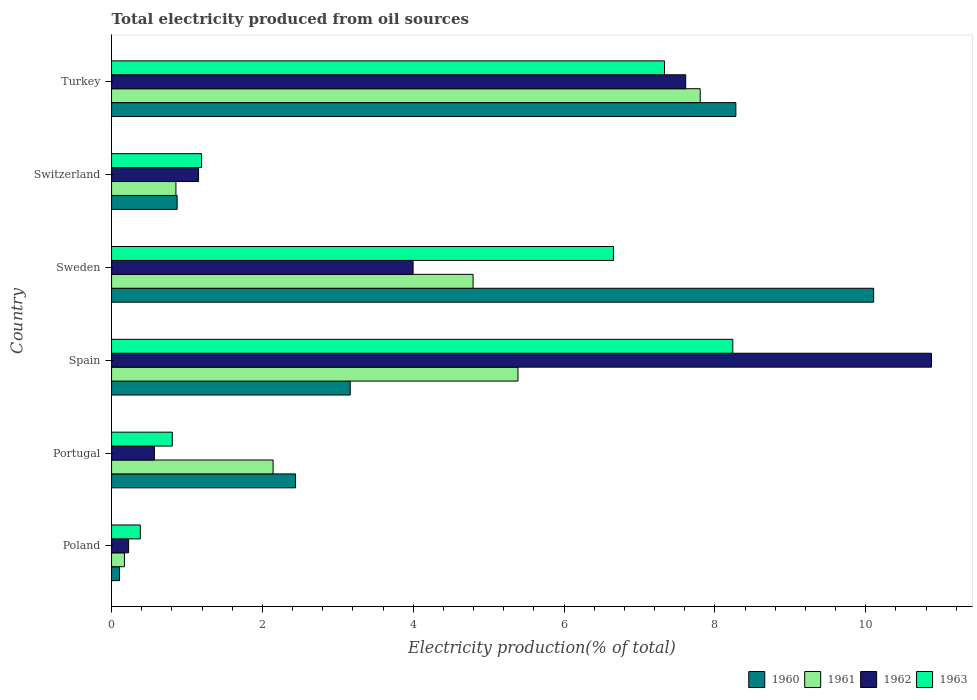Are the number of bars per tick equal to the number of legend labels?
Keep it short and to the point. Yes. What is the label of the 2nd group of bars from the top?
Keep it short and to the point. Switzerland. In how many cases, is the number of bars for a given country not equal to the number of legend labels?
Make the answer very short. 0. What is the total electricity produced in 1960 in Portugal?
Your response must be concise. 2.44. Across all countries, what is the maximum total electricity produced in 1962?
Provide a short and direct response. 10.87. Across all countries, what is the minimum total electricity produced in 1963?
Your response must be concise. 0.38. In which country was the total electricity produced in 1963 maximum?
Ensure brevity in your answer.  Spain. In which country was the total electricity produced in 1963 minimum?
Provide a short and direct response. Poland. What is the total total electricity produced in 1961 in the graph?
Provide a short and direct response. 21.15. What is the difference between the total electricity produced in 1963 in Poland and that in Switzerland?
Provide a short and direct response. -0.81. What is the difference between the total electricity produced in 1963 in Portugal and the total electricity produced in 1962 in Spain?
Offer a terse response. -10.07. What is the average total electricity produced in 1962 per country?
Your response must be concise. 4.07. What is the difference between the total electricity produced in 1961 and total electricity produced in 1960 in Portugal?
Your response must be concise. -0.3. What is the ratio of the total electricity produced in 1963 in Portugal to that in Spain?
Your answer should be very brief. 0.1. Is the difference between the total electricity produced in 1961 in Poland and Portugal greater than the difference between the total electricity produced in 1960 in Poland and Portugal?
Make the answer very short. Yes. What is the difference between the highest and the second highest total electricity produced in 1962?
Ensure brevity in your answer.  3.26. What is the difference between the highest and the lowest total electricity produced in 1960?
Provide a short and direct response. 10. In how many countries, is the total electricity produced in 1961 greater than the average total electricity produced in 1961 taken over all countries?
Offer a very short reply. 3. What does the 1st bar from the top in Switzerland represents?
Your answer should be compact. 1963. Is it the case that in every country, the sum of the total electricity produced in 1961 and total electricity produced in 1960 is greater than the total electricity produced in 1963?
Offer a terse response. No. How many bars are there?
Your answer should be very brief. 24. How many legend labels are there?
Provide a succinct answer. 4. How are the legend labels stacked?
Provide a succinct answer. Horizontal. What is the title of the graph?
Give a very brief answer. Total electricity produced from oil sources. Does "1960" appear as one of the legend labels in the graph?
Provide a short and direct response. Yes. What is the label or title of the X-axis?
Your answer should be very brief. Electricity production(% of total). What is the Electricity production(% of total) of 1960 in Poland?
Your answer should be very brief. 0.11. What is the Electricity production(% of total) of 1961 in Poland?
Keep it short and to the point. 0.17. What is the Electricity production(% of total) in 1962 in Poland?
Give a very brief answer. 0.23. What is the Electricity production(% of total) in 1963 in Poland?
Your response must be concise. 0.38. What is the Electricity production(% of total) of 1960 in Portugal?
Provide a succinct answer. 2.44. What is the Electricity production(% of total) of 1961 in Portugal?
Give a very brief answer. 2.14. What is the Electricity production(% of total) of 1962 in Portugal?
Provide a succinct answer. 0.57. What is the Electricity production(% of total) in 1963 in Portugal?
Your response must be concise. 0.81. What is the Electricity production(% of total) of 1960 in Spain?
Offer a terse response. 3.16. What is the Electricity production(% of total) of 1961 in Spain?
Your answer should be very brief. 5.39. What is the Electricity production(% of total) of 1962 in Spain?
Provide a succinct answer. 10.87. What is the Electricity production(% of total) in 1963 in Spain?
Ensure brevity in your answer.  8.24. What is the Electricity production(% of total) of 1960 in Sweden?
Ensure brevity in your answer.  10.1. What is the Electricity production(% of total) in 1961 in Sweden?
Ensure brevity in your answer.  4.79. What is the Electricity production(% of total) of 1962 in Sweden?
Keep it short and to the point. 4. What is the Electricity production(% of total) of 1963 in Sweden?
Offer a terse response. 6.66. What is the Electricity production(% of total) in 1960 in Switzerland?
Your answer should be very brief. 0.87. What is the Electricity production(% of total) in 1961 in Switzerland?
Offer a very short reply. 0.85. What is the Electricity production(% of total) in 1962 in Switzerland?
Make the answer very short. 1.15. What is the Electricity production(% of total) of 1963 in Switzerland?
Your response must be concise. 1.19. What is the Electricity production(% of total) in 1960 in Turkey?
Offer a very short reply. 8.28. What is the Electricity production(% of total) of 1961 in Turkey?
Offer a very short reply. 7.8. What is the Electricity production(% of total) in 1962 in Turkey?
Give a very brief answer. 7.61. What is the Electricity production(% of total) of 1963 in Turkey?
Offer a terse response. 7.33. Across all countries, what is the maximum Electricity production(% of total) in 1960?
Your response must be concise. 10.1. Across all countries, what is the maximum Electricity production(% of total) of 1961?
Your answer should be compact. 7.8. Across all countries, what is the maximum Electricity production(% of total) in 1962?
Offer a very short reply. 10.87. Across all countries, what is the maximum Electricity production(% of total) in 1963?
Keep it short and to the point. 8.24. Across all countries, what is the minimum Electricity production(% of total) in 1960?
Offer a very short reply. 0.11. Across all countries, what is the minimum Electricity production(% of total) of 1961?
Keep it short and to the point. 0.17. Across all countries, what is the minimum Electricity production(% of total) in 1962?
Provide a short and direct response. 0.23. Across all countries, what is the minimum Electricity production(% of total) of 1963?
Provide a short and direct response. 0.38. What is the total Electricity production(% of total) of 1960 in the graph?
Provide a succinct answer. 24.96. What is the total Electricity production(% of total) of 1961 in the graph?
Provide a succinct answer. 21.15. What is the total Electricity production(% of total) in 1962 in the graph?
Ensure brevity in your answer.  24.43. What is the total Electricity production(% of total) of 1963 in the graph?
Give a very brief answer. 24.6. What is the difference between the Electricity production(% of total) of 1960 in Poland and that in Portugal?
Offer a terse response. -2.33. What is the difference between the Electricity production(% of total) in 1961 in Poland and that in Portugal?
Your answer should be compact. -1.97. What is the difference between the Electricity production(% of total) of 1962 in Poland and that in Portugal?
Keep it short and to the point. -0.34. What is the difference between the Electricity production(% of total) of 1963 in Poland and that in Portugal?
Offer a very short reply. -0.42. What is the difference between the Electricity production(% of total) of 1960 in Poland and that in Spain?
Offer a very short reply. -3.06. What is the difference between the Electricity production(% of total) of 1961 in Poland and that in Spain?
Provide a succinct answer. -5.22. What is the difference between the Electricity production(% of total) in 1962 in Poland and that in Spain?
Your response must be concise. -10.64. What is the difference between the Electricity production(% of total) in 1963 in Poland and that in Spain?
Your answer should be very brief. -7.85. What is the difference between the Electricity production(% of total) of 1960 in Poland and that in Sweden?
Your answer should be compact. -10. What is the difference between the Electricity production(% of total) of 1961 in Poland and that in Sweden?
Your answer should be compact. -4.62. What is the difference between the Electricity production(% of total) of 1962 in Poland and that in Sweden?
Your response must be concise. -3.77. What is the difference between the Electricity production(% of total) in 1963 in Poland and that in Sweden?
Your response must be concise. -6.27. What is the difference between the Electricity production(% of total) in 1960 in Poland and that in Switzerland?
Your response must be concise. -0.76. What is the difference between the Electricity production(% of total) of 1961 in Poland and that in Switzerland?
Keep it short and to the point. -0.68. What is the difference between the Electricity production(% of total) in 1962 in Poland and that in Switzerland?
Keep it short and to the point. -0.93. What is the difference between the Electricity production(% of total) of 1963 in Poland and that in Switzerland?
Your answer should be very brief. -0.81. What is the difference between the Electricity production(% of total) in 1960 in Poland and that in Turkey?
Offer a terse response. -8.17. What is the difference between the Electricity production(% of total) in 1961 in Poland and that in Turkey?
Ensure brevity in your answer.  -7.63. What is the difference between the Electricity production(% of total) of 1962 in Poland and that in Turkey?
Your answer should be very brief. -7.39. What is the difference between the Electricity production(% of total) in 1963 in Poland and that in Turkey?
Ensure brevity in your answer.  -6.95. What is the difference between the Electricity production(% of total) in 1960 in Portugal and that in Spain?
Provide a succinct answer. -0.72. What is the difference between the Electricity production(% of total) of 1961 in Portugal and that in Spain?
Offer a very short reply. -3.25. What is the difference between the Electricity production(% of total) in 1962 in Portugal and that in Spain?
Make the answer very short. -10.3. What is the difference between the Electricity production(% of total) in 1963 in Portugal and that in Spain?
Your response must be concise. -7.43. What is the difference between the Electricity production(% of total) in 1960 in Portugal and that in Sweden?
Your response must be concise. -7.66. What is the difference between the Electricity production(% of total) of 1961 in Portugal and that in Sweden?
Offer a terse response. -2.65. What is the difference between the Electricity production(% of total) in 1962 in Portugal and that in Sweden?
Keep it short and to the point. -3.43. What is the difference between the Electricity production(% of total) of 1963 in Portugal and that in Sweden?
Provide a succinct answer. -5.85. What is the difference between the Electricity production(% of total) of 1960 in Portugal and that in Switzerland?
Give a very brief answer. 1.57. What is the difference between the Electricity production(% of total) in 1961 in Portugal and that in Switzerland?
Provide a succinct answer. 1.29. What is the difference between the Electricity production(% of total) of 1962 in Portugal and that in Switzerland?
Make the answer very short. -0.59. What is the difference between the Electricity production(% of total) of 1963 in Portugal and that in Switzerland?
Offer a very short reply. -0.39. What is the difference between the Electricity production(% of total) of 1960 in Portugal and that in Turkey?
Your response must be concise. -5.84. What is the difference between the Electricity production(% of total) in 1961 in Portugal and that in Turkey?
Offer a very short reply. -5.66. What is the difference between the Electricity production(% of total) in 1962 in Portugal and that in Turkey?
Provide a short and direct response. -7.04. What is the difference between the Electricity production(% of total) of 1963 in Portugal and that in Turkey?
Make the answer very short. -6.53. What is the difference between the Electricity production(% of total) of 1960 in Spain and that in Sweden?
Provide a short and direct response. -6.94. What is the difference between the Electricity production(% of total) of 1961 in Spain and that in Sweden?
Keep it short and to the point. 0.6. What is the difference between the Electricity production(% of total) of 1962 in Spain and that in Sweden?
Offer a very short reply. 6.87. What is the difference between the Electricity production(% of total) in 1963 in Spain and that in Sweden?
Your answer should be very brief. 1.58. What is the difference between the Electricity production(% of total) in 1960 in Spain and that in Switzerland?
Keep it short and to the point. 2.29. What is the difference between the Electricity production(% of total) in 1961 in Spain and that in Switzerland?
Keep it short and to the point. 4.53. What is the difference between the Electricity production(% of total) of 1962 in Spain and that in Switzerland?
Keep it short and to the point. 9.72. What is the difference between the Electricity production(% of total) in 1963 in Spain and that in Switzerland?
Provide a succinct answer. 7.04. What is the difference between the Electricity production(% of total) of 1960 in Spain and that in Turkey?
Provide a succinct answer. -5.11. What is the difference between the Electricity production(% of total) of 1961 in Spain and that in Turkey?
Your answer should be compact. -2.42. What is the difference between the Electricity production(% of total) in 1962 in Spain and that in Turkey?
Give a very brief answer. 3.26. What is the difference between the Electricity production(% of total) of 1963 in Spain and that in Turkey?
Your answer should be compact. 0.91. What is the difference between the Electricity production(% of total) in 1960 in Sweden and that in Switzerland?
Keep it short and to the point. 9.23. What is the difference between the Electricity production(% of total) in 1961 in Sweden and that in Switzerland?
Your response must be concise. 3.94. What is the difference between the Electricity production(% of total) of 1962 in Sweden and that in Switzerland?
Provide a short and direct response. 2.84. What is the difference between the Electricity production(% of total) of 1963 in Sweden and that in Switzerland?
Offer a very short reply. 5.46. What is the difference between the Electricity production(% of total) of 1960 in Sweden and that in Turkey?
Offer a very short reply. 1.83. What is the difference between the Electricity production(% of total) in 1961 in Sweden and that in Turkey?
Give a very brief answer. -3.01. What is the difference between the Electricity production(% of total) in 1962 in Sweden and that in Turkey?
Offer a very short reply. -3.61. What is the difference between the Electricity production(% of total) in 1963 in Sweden and that in Turkey?
Offer a very short reply. -0.68. What is the difference between the Electricity production(% of total) in 1960 in Switzerland and that in Turkey?
Make the answer very short. -7.41. What is the difference between the Electricity production(% of total) of 1961 in Switzerland and that in Turkey?
Your answer should be very brief. -6.95. What is the difference between the Electricity production(% of total) in 1962 in Switzerland and that in Turkey?
Your answer should be compact. -6.46. What is the difference between the Electricity production(% of total) in 1963 in Switzerland and that in Turkey?
Offer a very short reply. -6.14. What is the difference between the Electricity production(% of total) in 1960 in Poland and the Electricity production(% of total) in 1961 in Portugal?
Provide a succinct answer. -2.04. What is the difference between the Electricity production(% of total) of 1960 in Poland and the Electricity production(% of total) of 1962 in Portugal?
Offer a terse response. -0.46. What is the difference between the Electricity production(% of total) of 1960 in Poland and the Electricity production(% of total) of 1963 in Portugal?
Provide a short and direct response. -0.7. What is the difference between the Electricity production(% of total) of 1961 in Poland and the Electricity production(% of total) of 1962 in Portugal?
Make the answer very short. -0.4. What is the difference between the Electricity production(% of total) in 1961 in Poland and the Electricity production(% of total) in 1963 in Portugal?
Give a very brief answer. -0.63. What is the difference between the Electricity production(% of total) in 1962 in Poland and the Electricity production(% of total) in 1963 in Portugal?
Your answer should be very brief. -0.58. What is the difference between the Electricity production(% of total) of 1960 in Poland and the Electricity production(% of total) of 1961 in Spain?
Ensure brevity in your answer.  -5.28. What is the difference between the Electricity production(% of total) of 1960 in Poland and the Electricity production(% of total) of 1962 in Spain?
Provide a succinct answer. -10.77. What is the difference between the Electricity production(% of total) of 1960 in Poland and the Electricity production(% of total) of 1963 in Spain?
Your answer should be compact. -8.13. What is the difference between the Electricity production(% of total) in 1961 in Poland and the Electricity production(% of total) in 1962 in Spain?
Ensure brevity in your answer.  -10.7. What is the difference between the Electricity production(% of total) of 1961 in Poland and the Electricity production(% of total) of 1963 in Spain?
Offer a terse response. -8.07. What is the difference between the Electricity production(% of total) in 1962 in Poland and the Electricity production(% of total) in 1963 in Spain?
Make the answer very short. -8.01. What is the difference between the Electricity production(% of total) in 1960 in Poland and the Electricity production(% of total) in 1961 in Sweden?
Offer a terse response. -4.69. What is the difference between the Electricity production(% of total) in 1960 in Poland and the Electricity production(% of total) in 1962 in Sweden?
Your answer should be compact. -3.89. What is the difference between the Electricity production(% of total) in 1960 in Poland and the Electricity production(% of total) in 1963 in Sweden?
Your response must be concise. -6.55. What is the difference between the Electricity production(% of total) in 1961 in Poland and the Electricity production(% of total) in 1962 in Sweden?
Keep it short and to the point. -3.83. What is the difference between the Electricity production(% of total) of 1961 in Poland and the Electricity production(% of total) of 1963 in Sweden?
Ensure brevity in your answer.  -6.48. What is the difference between the Electricity production(% of total) of 1962 in Poland and the Electricity production(% of total) of 1963 in Sweden?
Your answer should be very brief. -6.43. What is the difference between the Electricity production(% of total) of 1960 in Poland and the Electricity production(% of total) of 1961 in Switzerland?
Your answer should be very brief. -0.75. What is the difference between the Electricity production(% of total) of 1960 in Poland and the Electricity production(% of total) of 1962 in Switzerland?
Your answer should be compact. -1.05. What is the difference between the Electricity production(% of total) of 1960 in Poland and the Electricity production(% of total) of 1963 in Switzerland?
Provide a succinct answer. -1.09. What is the difference between the Electricity production(% of total) of 1961 in Poland and the Electricity production(% of total) of 1962 in Switzerland?
Provide a succinct answer. -0.98. What is the difference between the Electricity production(% of total) of 1961 in Poland and the Electricity production(% of total) of 1963 in Switzerland?
Provide a succinct answer. -1.02. What is the difference between the Electricity production(% of total) of 1962 in Poland and the Electricity production(% of total) of 1963 in Switzerland?
Provide a short and direct response. -0.97. What is the difference between the Electricity production(% of total) of 1960 in Poland and the Electricity production(% of total) of 1961 in Turkey?
Give a very brief answer. -7.7. What is the difference between the Electricity production(% of total) of 1960 in Poland and the Electricity production(% of total) of 1962 in Turkey?
Offer a very short reply. -7.51. What is the difference between the Electricity production(% of total) of 1960 in Poland and the Electricity production(% of total) of 1963 in Turkey?
Your answer should be very brief. -7.23. What is the difference between the Electricity production(% of total) of 1961 in Poland and the Electricity production(% of total) of 1962 in Turkey?
Provide a short and direct response. -7.44. What is the difference between the Electricity production(% of total) of 1961 in Poland and the Electricity production(% of total) of 1963 in Turkey?
Make the answer very short. -7.16. What is the difference between the Electricity production(% of total) of 1962 in Poland and the Electricity production(% of total) of 1963 in Turkey?
Provide a succinct answer. -7.1. What is the difference between the Electricity production(% of total) in 1960 in Portugal and the Electricity production(% of total) in 1961 in Spain?
Your response must be concise. -2.95. What is the difference between the Electricity production(% of total) of 1960 in Portugal and the Electricity production(% of total) of 1962 in Spain?
Offer a very short reply. -8.43. What is the difference between the Electricity production(% of total) in 1960 in Portugal and the Electricity production(% of total) in 1963 in Spain?
Make the answer very short. -5.8. What is the difference between the Electricity production(% of total) of 1961 in Portugal and the Electricity production(% of total) of 1962 in Spain?
Keep it short and to the point. -8.73. What is the difference between the Electricity production(% of total) of 1961 in Portugal and the Electricity production(% of total) of 1963 in Spain?
Make the answer very short. -6.09. What is the difference between the Electricity production(% of total) of 1962 in Portugal and the Electricity production(% of total) of 1963 in Spain?
Offer a very short reply. -7.67. What is the difference between the Electricity production(% of total) in 1960 in Portugal and the Electricity production(% of total) in 1961 in Sweden?
Give a very brief answer. -2.35. What is the difference between the Electricity production(% of total) of 1960 in Portugal and the Electricity production(% of total) of 1962 in Sweden?
Give a very brief answer. -1.56. What is the difference between the Electricity production(% of total) in 1960 in Portugal and the Electricity production(% of total) in 1963 in Sweden?
Provide a succinct answer. -4.22. What is the difference between the Electricity production(% of total) in 1961 in Portugal and the Electricity production(% of total) in 1962 in Sweden?
Offer a terse response. -1.86. What is the difference between the Electricity production(% of total) in 1961 in Portugal and the Electricity production(% of total) in 1963 in Sweden?
Make the answer very short. -4.51. What is the difference between the Electricity production(% of total) of 1962 in Portugal and the Electricity production(% of total) of 1963 in Sweden?
Your response must be concise. -6.09. What is the difference between the Electricity production(% of total) of 1960 in Portugal and the Electricity production(% of total) of 1961 in Switzerland?
Keep it short and to the point. 1.59. What is the difference between the Electricity production(% of total) of 1960 in Portugal and the Electricity production(% of total) of 1962 in Switzerland?
Provide a succinct answer. 1.29. What is the difference between the Electricity production(% of total) in 1960 in Portugal and the Electricity production(% of total) in 1963 in Switzerland?
Your response must be concise. 1.25. What is the difference between the Electricity production(% of total) in 1961 in Portugal and the Electricity production(% of total) in 1962 in Switzerland?
Your response must be concise. 0.99. What is the difference between the Electricity production(% of total) in 1961 in Portugal and the Electricity production(% of total) in 1963 in Switzerland?
Ensure brevity in your answer.  0.95. What is the difference between the Electricity production(% of total) of 1962 in Portugal and the Electricity production(% of total) of 1963 in Switzerland?
Make the answer very short. -0.63. What is the difference between the Electricity production(% of total) of 1960 in Portugal and the Electricity production(% of total) of 1961 in Turkey?
Make the answer very short. -5.36. What is the difference between the Electricity production(% of total) of 1960 in Portugal and the Electricity production(% of total) of 1962 in Turkey?
Provide a short and direct response. -5.17. What is the difference between the Electricity production(% of total) of 1960 in Portugal and the Electricity production(% of total) of 1963 in Turkey?
Give a very brief answer. -4.89. What is the difference between the Electricity production(% of total) in 1961 in Portugal and the Electricity production(% of total) in 1962 in Turkey?
Make the answer very short. -5.47. What is the difference between the Electricity production(% of total) in 1961 in Portugal and the Electricity production(% of total) in 1963 in Turkey?
Make the answer very short. -5.19. What is the difference between the Electricity production(% of total) in 1962 in Portugal and the Electricity production(% of total) in 1963 in Turkey?
Offer a very short reply. -6.76. What is the difference between the Electricity production(% of total) in 1960 in Spain and the Electricity production(% of total) in 1961 in Sweden?
Give a very brief answer. -1.63. What is the difference between the Electricity production(% of total) in 1960 in Spain and the Electricity production(% of total) in 1963 in Sweden?
Provide a short and direct response. -3.49. What is the difference between the Electricity production(% of total) of 1961 in Spain and the Electricity production(% of total) of 1962 in Sweden?
Provide a succinct answer. 1.39. What is the difference between the Electricity production(% of total) of 1961 in Spain and the Electricity production(% of total) of 1963 in Sweden?
Provide a succinct answer. -1.27. What is the difference between the Electricity production(% of total) of 1962 in Spain and the Electricity production(% of total) of 1963 in Sweden?
Your response must be concise. 4.22. What is the difference between the Electricity production(% of total) of 1960 in Spain and the Electricity production(% of total) of 1961 in Switzerland?
Ensure brevity in your answer.  2.31. What is the difference between the Electricity production(% of total) of 1960 in Spain and the Electricity production(% of total) of 1962 in Switzerland?
Your answer should be compact. 2.01. What is the difference between the Electricity production(% of total) of 1960 in Spain and the Electricity production(% of total) of 1963 in Switzerland?
Offer a very short reply. 1.97. What is the difference between the Electricity production(% of total) in 1961 in Spain and the Electricity production(% of total) in 1962 in Switzerland?
Give a very brief answer. 4.24. What is the difference between the Electricity production(% of total) of 1961 in Spain and the Electricity production(% of total) of 1963 in Switzerland?
Offer a terse response. 4.2. What is the difference between the Electricity production(% of total) in 1962 in Spain and the Electricity production(% of total) in 1963 in Switzerland?
Ensure brevity in your answer.  9.68. What is the difference between the Electricity production(% of total) in 1960 in Spain and the Electricity production(% of total) in 1961 in Turkey?
Make the answer very short. -4.64. What is the difference between the Electricity production(% of total) in 1960 in Spain and the Electricity production(% of total) in 1962 in Turkey?
Your response must be concise. -4.45. What is the difference between the Electricity production(% of total) of 1960 in Spain and the Electricity production(% of total) of 1963 in Turkey?
Your answer should be compact. -4.17. What is the difference between the Electricity production(% of total) of 1961 in Spain and the Electricity production(% of total) of 1962 in Turkey?
Offer a terse response. -2.22. What is the difference between the Electricity production(% of total) in 1961 in Spain and the Electricity production(% of total) in 1963 in Turkey?
Offer a very short reply. -1.94. What is the difference between the Electricity production(% of total) of 1962 in Spain and the Electricity production(% of total) of 1963 in Turkey?
Your answer should be very brief. 3.54. What is the difference between the Electricity production(% of total) in 1960 in Sweden and the Electricity production(% of total) in 1961 in Switzerland?
Offer a very short reply. 9.25. What is the difference between the Electricity production(% of total) in 1960 in Sweden and the Electricity production(% of total) in 1962 in Switzerland?
Your answer should be very brief. 8.95. What is the difference between the Electricity production(% of total) in 1960 in Sweden and the Electricity production(% of total) in 1963 in Switzerland?
Your response must be concise. 8.91. What is the difference between the Electricity production(% of total) in 1961 in Sweden and the Electricity production(% of total) in 1962 in Switzerland?
Offer a very short reply. 3.64. What is the difference between the Electricity production(% of total) of 1962 in Sweden and the Electricity production(% of total) of 1963 in Switzerland?
Your response must be concise. 2.8. What is the difference between the Electricity production(% of total) of 1960 in Sweden and the Electricity production(% of total) of 1961 in Turkey?
Offer a very short reply. 2.3. What is the difference between the Electricity production(% of total) of 1960 in Sweden and the Electricity production(% of total) of 1962 in Turkey?
Provide a succinct answer. 2.49. What is the difference between the Electricity production(% of total) in 1960 in Sweden and the Electricity production(% of total) in 1963 in Turkey?
Ensure brevity in your answer.  2.77. What is the difference between the Electricity production(% of total) of 1961 in Sweden and the Electricity production(% of total) of 1962 in Turkey?
Your response must be concise. -2.82. What is the difference between the Electricity production(% of total) in 1961 in Sweden and the Electricity production(% of total) in 1963 in Turkey?
Give a very brief answer. -2.54. What is the difference between the Electricity production(% of total) of 1962 in Sweden and the Electricity production(% of total) of 1963 in Turkey?
Your response must be concise. -3.33. What is the difference between the Electricity production(% of total) of 1960 in Switzerland and the Electricity production(% of total) of 1961 in Turkey?
Give a very brief answer. -6.94. What is the difference between the Electricity production(% of total) in 1960 in Switzerland and the Electricity production(% of total) in 1962 in Turkey?
Provide a short and direct response. -6.74. What is the difference between the Electricity production(% of total) in 1960 in Switzerland and the Electricity production(% of total) in 1963 in Turkey?
Give a very brief answer. -6.46. What is the difference between the Electricity production(% of total) of 1961 in Switzerland and the Electricity production(% of total) of 1962 in Turkey?
Your answer should be very brief. -6.76. What is the difference between the Electricity production(% of total) in 1961 in Switzerland and the Electricity production(% of total) in 1963 in Turkey?
Ensure brevity in your answer.  -6.48. What is the difference between the Electricity production(% of total) in 1962 in Switzerland and the Electricity production(% of total) in 1963 in Turkey?
Ensure brevity in your answer.  -6.18. What is the average Electricity production(% of total) in 1960 per country?
Your answer should be compact. 4.16. What is the average Electricity production(% of total) in 1961 per country?
Offer a terse response. 3.53. What is the average Electricity production(% of total) of 1962 per country?
Your answer should be compact. 4.07. What is the average Electricity production(% of total) of 1963 per country?
Your answer should be compact. 4.1. What is the difference between the Electricity production(% of total) in 1960 and Electricity production(% of total) in 1961 in Poland?
Your answer should be very brief. -0.06. What is the difference between the Electricity production(% of total) of 1960 and Electricity production(% of total) of 1962 in Poland?
Offer a very short reply. -0.12. What is the difference between the Electricity production(% of total) of 1960 and Electricity production(% of total) of 1963 in Poland?
Provide a succinct answer. -0.28. What is the difference between the Electricity production(% of total) of 1961 and Electricity production(% of total) of 1962 in Poland?
Provide a short and direct response. -0.06. What is the difference between the Electricity production(% of total) of 1961 and Electricity production(% of total) of 1963 in Poland?
Your response must be concise. -0.21. What is the difference between the Electricity production(% of total) in 1962 and Electricity production(% of total) in 1963 in Poland?
Provide a succinct answer. -0.16. What is the difference between the Electricity production(% of total) of 1960 and Electricity production(% of total) of 1961 in Portugal?
Provide a short and direct response. 0.3. What is the difference between the Electricity production(% of total) in 1960 and Electricity production(% of total) in 1962 in Portugal?
Offer a very short reply. 1.87. What is the difference between the Electricity production(% of total) of 1960 and Electricity production(% of total) of 1963 in Portugal?
Provide a short and direct response. 1.63. What is the difference between the Electricity production(% of total) of 1961 and Electricity production(% of total) of 1962 in Portugal?
Ensure brevity in your answer.  1.57. What is the difference between the Electricity production(% of total) in 1961 and Electricity production(% of total) in 1963 in Portugal?
Your response must be concise. 1.34. What is the difference between the Electricity production(% of total) of 1962 and Electricity production(% of total) of 1963 in Portugal?
Keep it short and to the point. -0.24. What is the difference between the Electricity production(% of total) of 1960 and Electricity production(% of total) of 1961 in Spain?
Ensure brevity in your answer.  -2.22. What is the difference between the Electricity production(% of total) in 1960 and Electricity production(% of total) in 1962 in Spain?
Make the answer very short. -7.71. What is the difference between the Electricity production(% of total) of 1960 and Electricity production(% of total) of 1963 in Spain?
Keep it short and to the point. -5.07. What is the difference between the Electricity production(% of total) in 1961 and Electricity production(% of total) in 1962 in Spain?
Your answer should be compact. -5.48. What is the difference between the Electricity production(% of total) in 1961 and Electricity production(% of total) in 1963 in Spain?
Keep it short and to the point. -2.85. What is the difference between the Electricity production(% of total) of 1962 and Electricity production(% of total) of 1963 in Spain?
Your answer should be compact. 2.63. What is the difference between the Electricity production(% of total) in 1960 and Electricity production(% of total) in 1961 in Sweden?
Offer a terse response. 5.31. What is the difference between the Electricity production(% of total) in 1960 and Electricity production(% of total) in 1962 in Sweden?
Give a very brief answer. 6.11. What is the difference between the Electricity production(% of total) of 1960 and Electricity production(% of total) of 1963 in Sweden?
Offer a very short reply. 3.45. What is the difference between the Electricity production(% of total) of 1961 and Electricity production(% of total) of 1962 in Sweden?
Give a very brief answer. 0.8. What is the difference between the Electricity production(% of total) in 1961 and Electricity production(% of total) in 1963 in Sweden?
Provide a succinct answer. -1.86. What is the difference between the Electricity production(% of total) in 1962 and Electricity production(% of total) in 1963 in Sweden?
Make the answer very short. -2.66. What is the difference between the Electricity production(% of total) of 1960 and Electricity production(% of total) of 1961 in Switzerland?
Provide a succinct answer. 0.02. What is the difference between the Electricity production(% of total) in 1960 and Electricity production(% of total) in 1962 in Switzerland?
Offer a very short reply. -0.28. What is the difference between the Electricity production(% of total) in 1960 and Electricity production(% of total) in 1963 in Switzerland?
Your response must be concise. -0.32. What is the difference between the Electricity production(% of total) in 1961 and Electricity production(% of total) in 1962 in Switzerland?
Your response must be concise. -0.3. What is the difference between the Electricity production(% of total) in 1961 and Electricity production(% of total) in 1963 in Switzerland?
Offer a very short reply. -0.34. What is the difference between the Electricity production(% of total) of 1962 and Electricity production(% of total) of 1963 in Switzerland?
Make the answer very short. -0.04. What is the difference between the Electricity production(% of total) of 1960 and Electricity production(% of total) of 1961 in Turkey?
Make the answer very short. 0.47. What is the difference between the Electricity production(% of total) in 1960 and Electricity production(% of total) in 1962 in Turkey?
Give a very brief answer. 0.66. What is the difference between the Electricity production(% of total) of 1960 and Electricity production(% of total) of 1963 in Turkey?
Ensure brevity in your answer.  0.95. What is the difference between the Electricity production(% of total) of 1961 and Electricity production(% of total) of 1962 in Turkey?
Provide a succinct answer. 0.19. What is the difference between the Electricity production(% of total) in 1961 and Electricity production(% of total) in 1963 in Turkey?
Provide a succinct answer. 0.47. What is the difference between the Electricity production(% of total) in 1962 and Electricity production(% of total) in 1963 in Turkey?
Offer a very short reply. 0.28. What is the ratio of the Electricity production(% of total) of 1960 in Poland to that in Portugal?
Offer a very short reply. 0.04. What is the ratio of the Electricity production(% of total) in 1961 in Poland to that in Portugal?
Provide a succinct answer. 0.08. What is the ratio of the Electricity production(% of total) of 1962 in Poland to that in Portugal?
Provide a succinct answer. 0.4. What is the ratio of the Electricity production(% of total) of 1963 in Poland to that in Portugal?
Your answer should be compact. 0.47. What is the ratio of the Electricity production(% of total) of 1960 in Poland to that in Spain?
Make the answer very short. 0.03. What is the ratio of the Electricity production(% of total) in 1961 in Poland to that in Spain?
Provide a succinct answer. 0.03. What is the ratio of the Electricity production(% of total) of 1962 in Poland to that in Spain?
Offer a very short reply. 0.02. What is the ratio of the Electricity production(% of total) of 1963 in Poland to that in Spain?
Keep it short and to the point. 0.05. What is the ratio of the Electricity production(% of total) in 1960 in Poland to that in Sweden?
Your response must be concise. 0.01. What is the ratio of the Electricity production(% of total) of 1961 in Poland to that in Sweden?
Your answer should be very brief. 0.04. What is the ratio of the Electricity production(% of total) of 1962 in Poland to that in Sweden?
Ensure brevity in your answer.  0.06. What is the ratio of the Electricity production(% of total) of 1963 in Poland to that in Sweden?
Offer a very short reply. 0.06. What is the ratio of the Electricity production(% of total) in 1960 in Poland to that in Switzerland?
Provide a succinct answer. 0.12. What is the ratio of the Electricity production(% of total) in 1961 in Poland to that in Switzerland?
Ensure brevity in your answer.  0.2. What is the ratio of the Electricity production(% of total) of 1962 in Poland to that in Switzerland?
Ensure brevity in your answer.  0.2. What is the ratio of the Electricity production(% of total) of 1963 in Poland to that in Switzerland?
Your answer should be compact. 0.32. What is the ratio of the Electricity production(% of total) in 1960 in Poland to that in Turkey?
Provide a succinct answer. 0.01. What is the ratio of the Electricity production(% of total) in 1961 in Poland to that in Turkey?
Offer a terse response. 0.02. What is the ratio of the Electricity production(% of total) in 1962 in Poland to that in Turkey?
Provide a short and direct response. 0.03. What is the ratio of the Electricity production(% of total) of 1963 in Poland to that in Turkey?
Provide a short and direct response. 0.05. What is the ratio of the Electricity production(% of total) in 1960 in Portugal to that in Spain?
Your answer should be compact. 0.77. What is the ratio of the Electricity production(% of total) of 1961 in Portugal to that in Spain?
Your answer should be very brief. 0.4. What is the ratio of the Electricity production(% of total) in 1962 in Portugal to that in Spain?
Ensure brevity in your answer.  0.05. What is the ratio of the Electricity production(% of total) in 1963 in Portugal to that in Spain?
Give a very brief answer. 0.1. What is the ratio of the Electricity production(% of total) in 1960 in Portugal to that in Sweden?
Offer a very short reply. 0.24. What is the ratio of the Electricity production(% of total) in 1961 in Portugal to that in Sweden?
Offer a very short reply. 0.45. What is the ratio of the Electricity production(% of total) in 1962 in Portugal to that in Sweden?
Provide a short and direct response. 0.14. What is the ratio of the Electricity production(% of total) in 1963 in Portugal to that in Sweden?
Provide a short and direct response. 0.12. What is the ratio of the Electricity production(% of total) of 1960 in Portugal to that in Switzerland?
Ensure brevity in your answer.  2.81. What is the ratio of the Electricity production(% of total) in 1961 in Portugal to that in Switzerland?
Offer a very short reply. 2.51. What is the ratio of the Electricity production(% of total) of 1962 in Portugal to that in Switzerland?
Give a very brief answer. 0.49. What is the ratio of the Electricity production(% of total) in 1963 in Portugal to that in Switzerland?
Your answer should be compact. 0.67. What is the ratio of the Electricity production(% of total) of 1960 in Portugal to that in Turkey?
Make the answer very short. 0.29. What is the ratio of the Electricity production(% of total) of 1961 in Portugal to that in Turkey?
Your response must be concise. 0.27. What is the ratio of the Electricity production(% of total) of 1962 in Portugal to that in Turkey?
Ensure brevity in your answer.  0.07. What is the ratio of the Electricity production(% of total) in 1963 in Portugal to that in Turkey?
Provide a succinct answer. 0.11. What is the ratio of the Electricity production(% of total) of 1960 in Spain to that in Sweden?
Offer a very short reply. 0.31. What is the ratio of the Electricity production(% of total) of 1961 in Spain to that in Sweden?
Make the answer very short. 1.12. What is the ratio of the Electricity production(% of total) in 1962 in Spain to that in Sweden?
Provide a succinct answer. 2.72. What is the ratio of the Electricity production(% of total) in 1963 in Spain to that in Sweden?
Keep it short and to the point. 1.24. What is the ratio of the Electricity production(% of total) of 1960 in Spain to that in Switzerland?
Give a very brief answer. 3.64. What is the ratio of the Electricity production(% of total) in 1961 in Spain to that in Switzerland?
Provide a succinct answer. 6.31. What is the ratio of the Electricity production(% of total) of 1962 in Spain to that in Switzerland?
Make the answer very short. 9.43. What is the ratio of the Electricity production(% of total) of 1963 in Spain to that in Switzerland?
Your answer should be compact. 6.9. What is the ratio of the Electricity production(% of total) of 1960 in Spain to that in Turkey?
Your response must be concise. 0.38. What is the ratio of the Electricity production(% of total) in 1961 in Spain to that in Turkey?
Provide a succinct answer. 0.69. What is the ratio of the Electricity production(% of total) in 1962 in Spain to that in Turkey?
Offer a terse response. 1.43. What is the ratio of the Electricity production(% of total) in 1963 in Spain to that in Turkey?
Keep it short and to the point. 1.12. What is the ratio of the Electricity production(% of total) in 1960 in Sweden to that in Switzerland?
Offer a terse response. 11.62. What is the ratio of the Electricity production(% of total) in 1961 in Sweden to that in Switzerland?
Your answer should be compact. 5.62. What is the ratio of the Electricity production(% of total) of 1962 in Sweden to that in Switzerland?
Offer a very short reply. 3.47. What is the ratio of the Electricity production(% of total) of 1963 in Sweden to that in Switzerland?
Offer a very short reply. 5.58. What is the ratio of the Electricity production(% of total) of 1960 in Sweden to that in Turkey?
Your answer should be very brief. 1.22. What is the ratio of the Electricity production(% of total) in 1961 in Sweden to that in Turkey?
Offer a very short reply. 0.61. What is the ratio of the Electricity production(% of total) of 1962 in Sweden to that in Turkey?
Provide a succinct answer. 0.53. What is the ratio of the Electricity production(% of total) in 1963 in Sweden to that in Turkey?
Ensure brevity in your answer.  0.91. What is the ratio of the Electricity production(% of total) of 1960 in Switzerland to that in Turkey?
Your response must be concise. 0.11. What is the ratio of the Electricity production(% of total) in 1961 in Switzerland to that in Turkey?
Your response must be concise. 0.11. What is the ratio of the Electricity production(% of total) in 1962 in Switzerland to that in Turkey?
Make the answer very short. 0.15. What is the ratio of the Electricity production(% of total) of 1963 in Switzerland to that in Turkey?
Your answer should be very brief. 0.16. What is the difference between the highest and the second highest Electricity production(% of total) in 1960?
Make the answer very short. 1.83. What is the difference between the highest and the second highest Electricity production(% of total) of 1961?
Your answer should be compact. 2.42. What is the difference between the highest and the second highest Electricity production(% of total) in 1962?
Provide a short and direct response. 3.26. What is the difference between the highest and the second highest Electricity production(% of total) of 1963?
Make the answer very short. 0.91. What is the difference between the highest and the lowest Electricity production(% of total) in 1960?
Offer a terse response. 10. What is the difference between the highest and the lowest Electricity production(% of total) of 1961?
Provide a succinct answer. 7.63. What is the difference between the highest and the lowest Electricity production(% of total) in 1962?
Ensure brevity in your answer.  10.64. What is the difference between the highest and the lowest Electricity production(% of total) in 1963?
Offer a terse response. 7.85. 